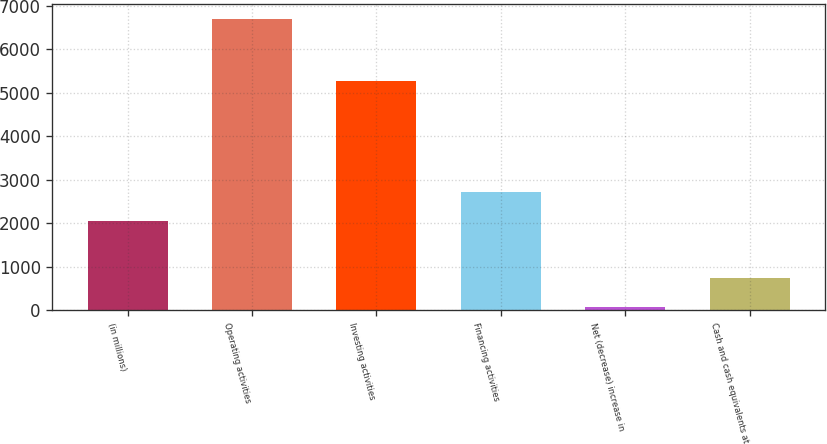Convert chart. <chart><loc_0><loc_0><loc_500><loc_500><bar_chart><fcel>(in millions)<fcel>Operating activities<fcel>Investing activities<fcel>Financing activities<fcel>Net (decrease) increase in<fcel>Cash and cash equivalents at<nl><fcel>2066<fcel>6700<fcel>5277<fcel>2728<fcel>80<fcel>742<nl></chart> 